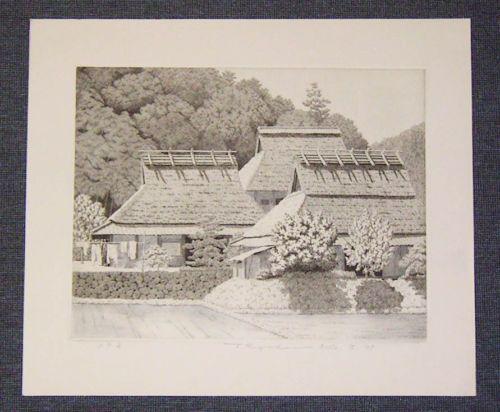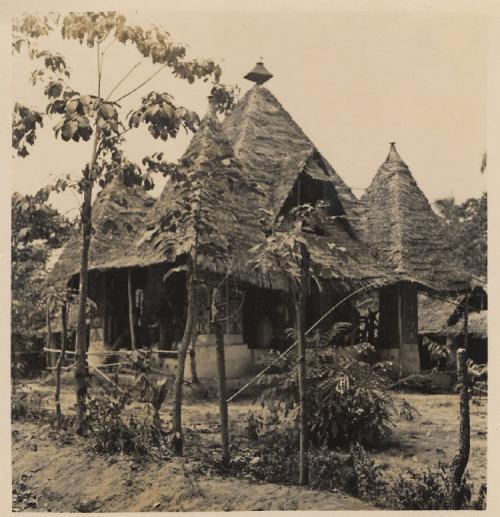The first image is the image on the left, the second image is the image on the right. Analyze the images presented: Is the assertion "There are people in front of a building." valid? Answer yes or no. No. 